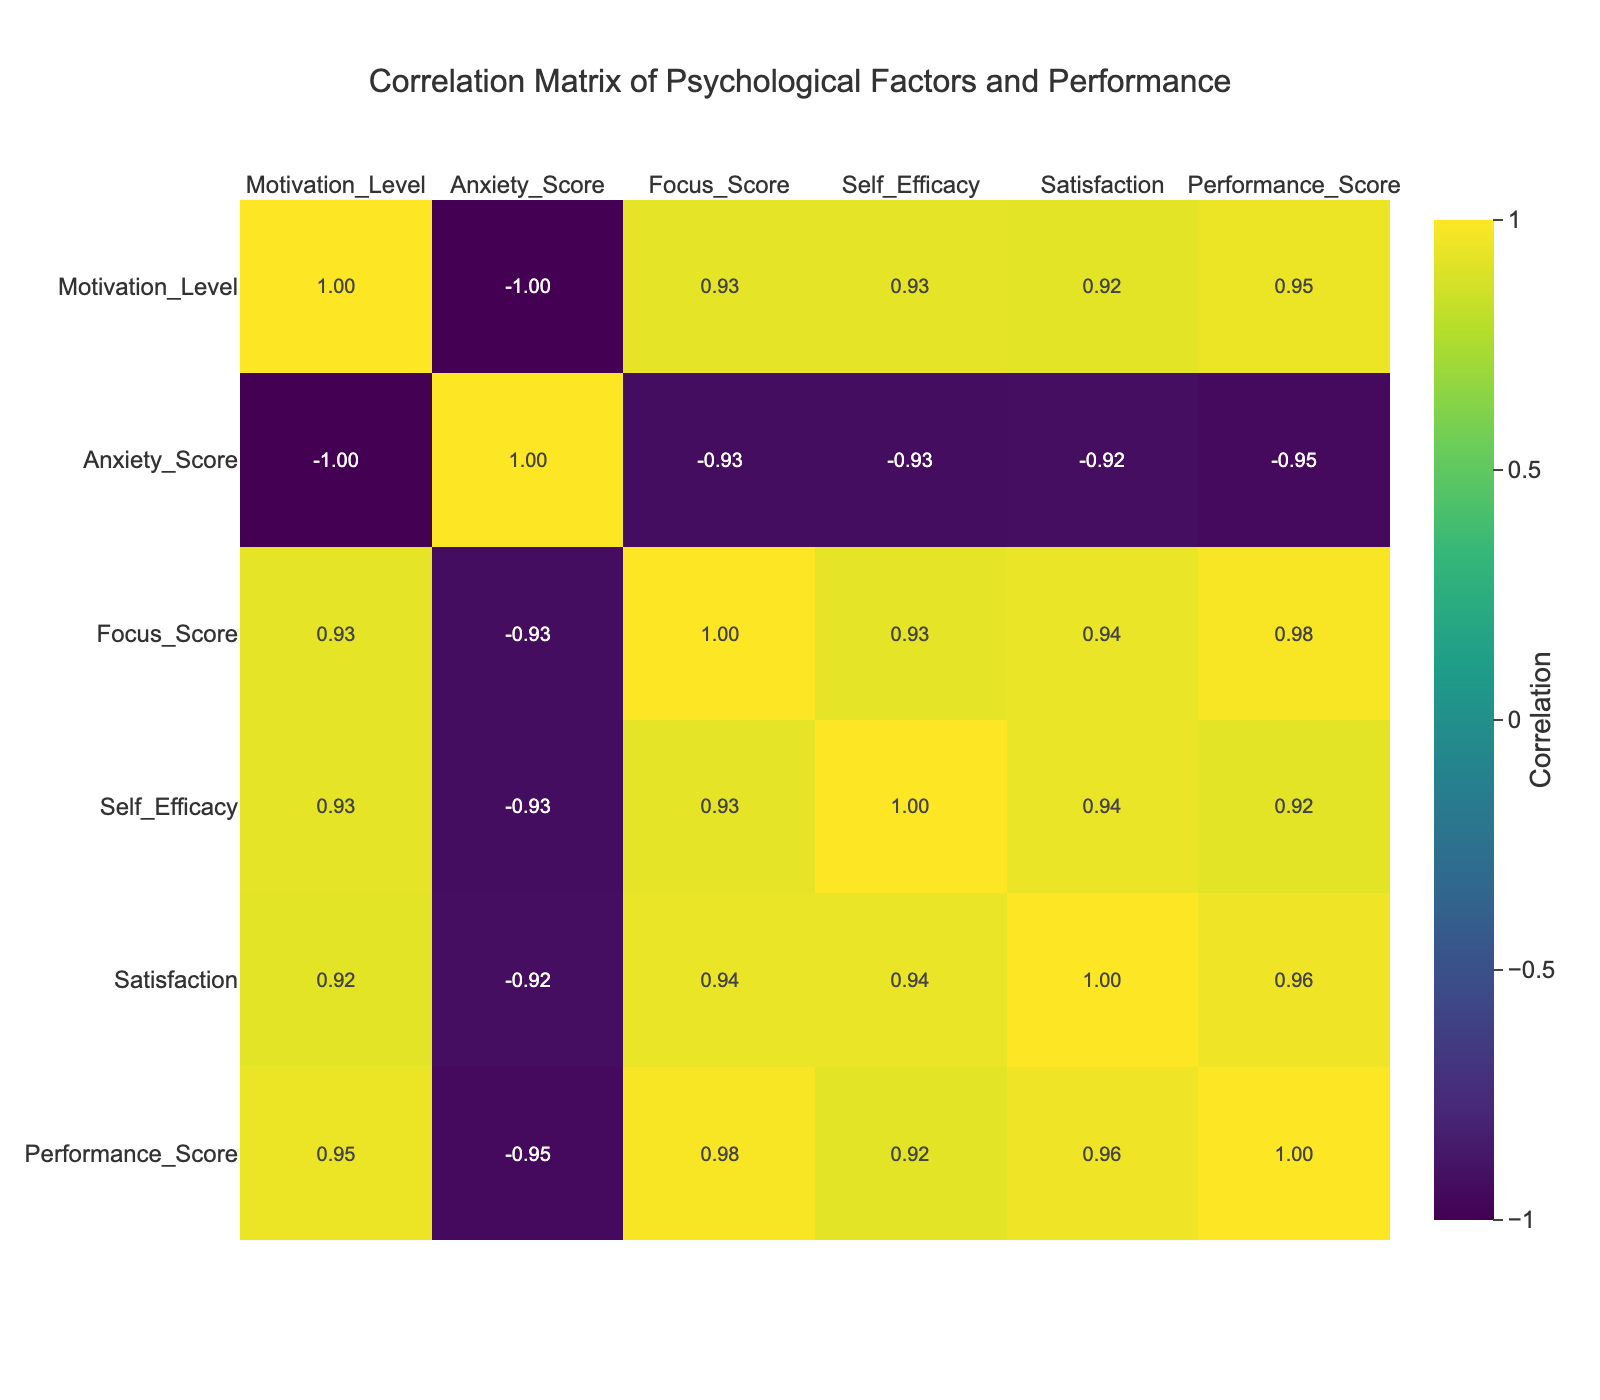What is the performance score of Adama Nguessan? From the table, I can locate Adama Nguessan in the first column and find that the Performance Score for this athlete is listed as 95.
Answer: 95 What is the correlation between Motivation Level and Performance Score? The table indicates that there is a strong positive correlation (0.93) between Motivation Level and Performance Score. This suggests that as motivation increases, performance tends to improve as well.
Answer: 0.93 Who has the highest Self-Efficacy score, and what is that score? A quick lookup through the Self-Efficacy column shows that Adama Nguessan has the highest Self-Efficacy score of 9.
Answer: Adama Nguessan; 9 Is there a negative correlation between Anxiety Score and Performance Score? Checking the correlation values in the table, the correlation between Anxiety Score and Performance Score is -0.90, which indicates a strong negative relationship, meaning that higher anxiety is associated with lower performance.
Answer: Yes What is the average Focus Score of athletes with a Performance Score greater than 80? From the table, the athletes with Performance Scores greater than 80 are Jean Boniface, Eric Nzue, Sandra Djoman, and Adama Nguessan. Their Focus Scores are 9, 10, 9, and 10 respectively. The average is calculated as (9 + 10 + 9 + 10) / 4 = 9.5.
Answer: 9.5 How many athletes have a Satisfaction score of less than 5? By inspecting the Satisfaction column, I see that only Odette Nzinga and Kouadio Seydou have Satisfaction scores lower than 5 (3 and 4 respectively). Therefore, there are 2 athletes.
Answer: 2 Which psychological factor shows the strongest positive correlation with Performance Score? The table indicates that Motivation Level has the strongest positive correlation with Performance Score at 0.93, suggesting it is the most influential psychological factor on performance.
Answer: Motivation Level How does the Self-Efficacy score of Eric Nzue compare to that of Aissatou Kouadio? Eric Nzue has a Self-Efficacy score of 9, while Aissatou Kouadio has a score of 5. Therefore, Eric Nzue's score is higher by a margin of 4 points.
Answer: Higher by 4 points Is it true that all athletes with a motivation level of 8 have a performance score above 85? Reviewing the table, Sandra Djoman has a Motivation Level of 8 but a Performance Score of 88, while Jean Boniface has a Performance Score of 85, which means that not all athletes with a score of 8 exceed 85.
Answer: No 